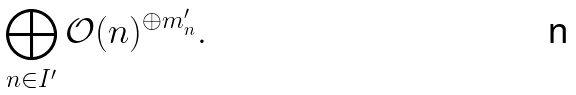Convert formula to latex. <formula><loc_0><loc_0><loc_500><loc_500>\bigoplus _ { n \in I ^ { \prime } } \mathcal { O } ( n ) ^ { \oplus m ^ { \prime } _ { n } } .</formula> 